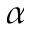Convert formula to latex. <formula><loc_0><loc_0><loc_500><loc_500>\alpha</formula> 